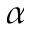Convert formula to latex. <formula><loc_0><loc_0><loc_500><loc_500>\alpha</formula> 